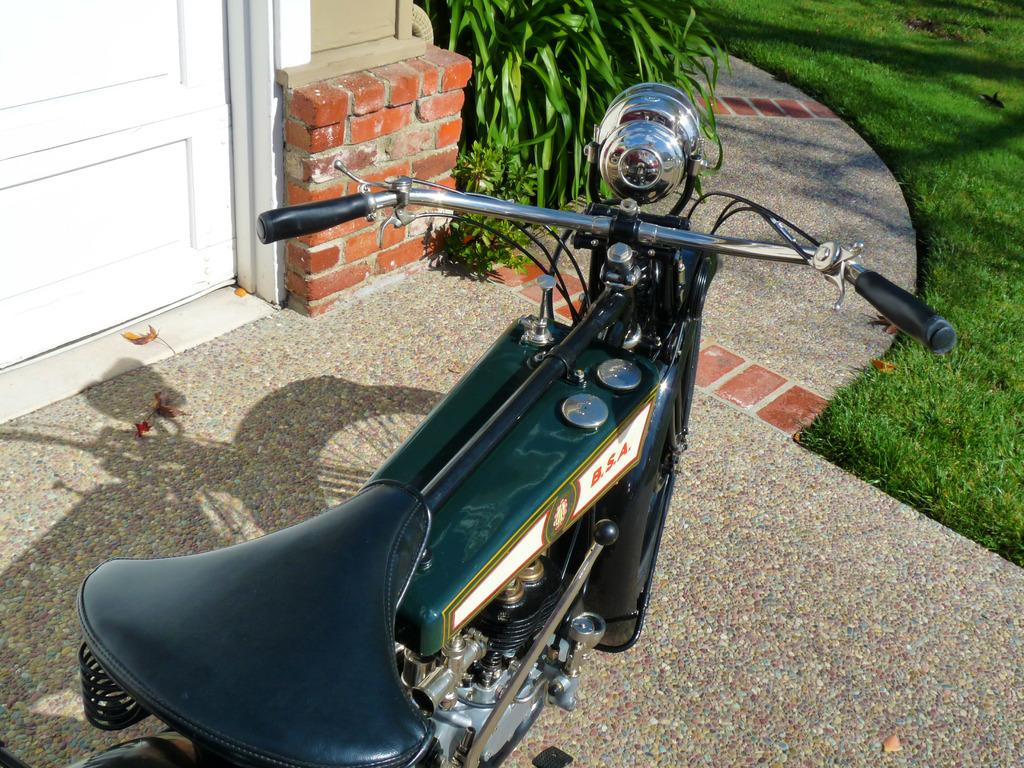What is the main subject of the image? There is a vehicle in the image. What type of vegetation can be seen on the right side of the image? There is grass on the right side of the image. Can you describe a specific feature of the image? There is a white door in the image. What flavor of development can be seen in the image? There is no development present in the image, and therefore no flavor can be associated with it. 